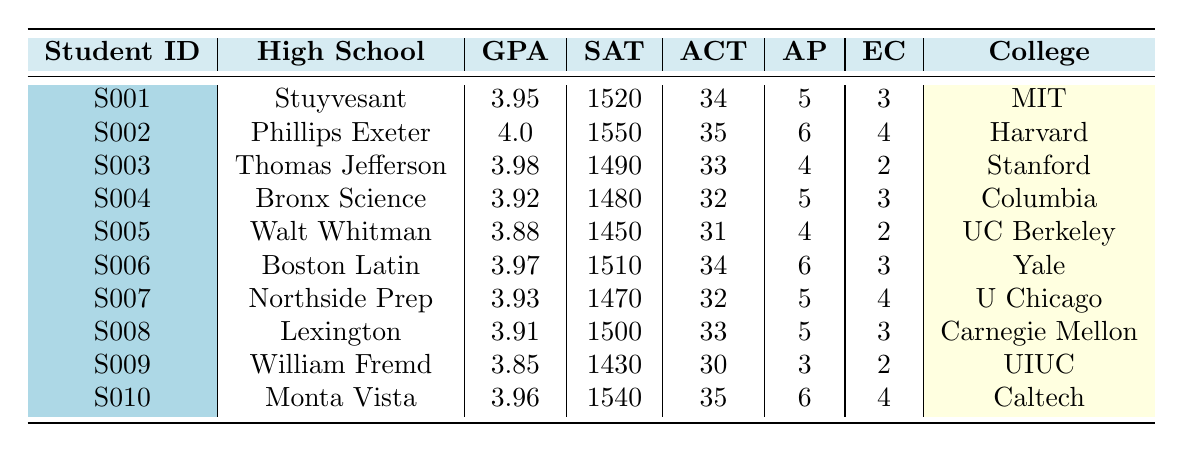What is the highest SAT score recorded in the table? The highest SAT score can be found by scanning through the SAT Score column. The highest value is 1550.
Answer: 1550 What is the High School GPA of the student admitted to Harvard University? To find this, locate Harvard University in the College Admitted column, then check the corresponding High School GPA for that student, which is 4.0.
Answer: 4.0 How many AP courses did the student from Northside College Preparatory High School take? Look for the entry for Northside College Preparatory High School in the High School column, and then check the AP Courses Taken column to find that the student took 5 AP courses.
Answer: 5 Which student has the lowest GPA, and what school did they attend? Review the GPA column to determine the lowest value, which is 3.85. The corresponding student ID is S009, and they attended William Fremd High School.
Answer: S009, William Fremd High School What is the average ACT score of all students listed in the table? First, sum all the ACT scores: (34 + 35 + 33 + 32 + 31 + 34 + 32 + 33 + 30 + 35) =  334. Then, divide by the number of students (10) to get the average, 334 / 10 = 33.4.
Answer: 33.4 How many students took 6 AP courses? Count the entries in the AP Courses Taken column that have the value 6. The students who took 6 AP courses are S002, S006, and S010, totaling 3 students.
Answer: 3 Is there a student from Phillips Exeter Academy who has an ACT score of 35? To verify this, find Phillips Exeter Academy in the High School column, and check if the corresponding ACT score is 35, which it is for student S002.
Answer: Yes Which college has the most students admitted according to the table? Look through the College Admitted column and count the occurrences of each college. Harvard University appears once (S002), while Stanford University, MIT, Columbia, UC Berkeley, Yale, U Chicago, Carnegie Mellon, UIUC, and Caltech also each appear once. Thus, no college has more than one student admitted.
Answer: No college has more students What is the difference between the highest SAT score and the lowest SAT score? Identify the highest SAT score (1550) and the lowest (1430). Then, calculate the difference: 1550 - 1430 = 120.
Answer: 120 What percentage of students have a GPA higher than 3.90? Count the number of students with a GPA greater than 3.90 (S001, S002, S003, S006, S010) which totals 5 students. Then calculate the percentage: (5/10) * 100 = 50%.
Answer: 50% 